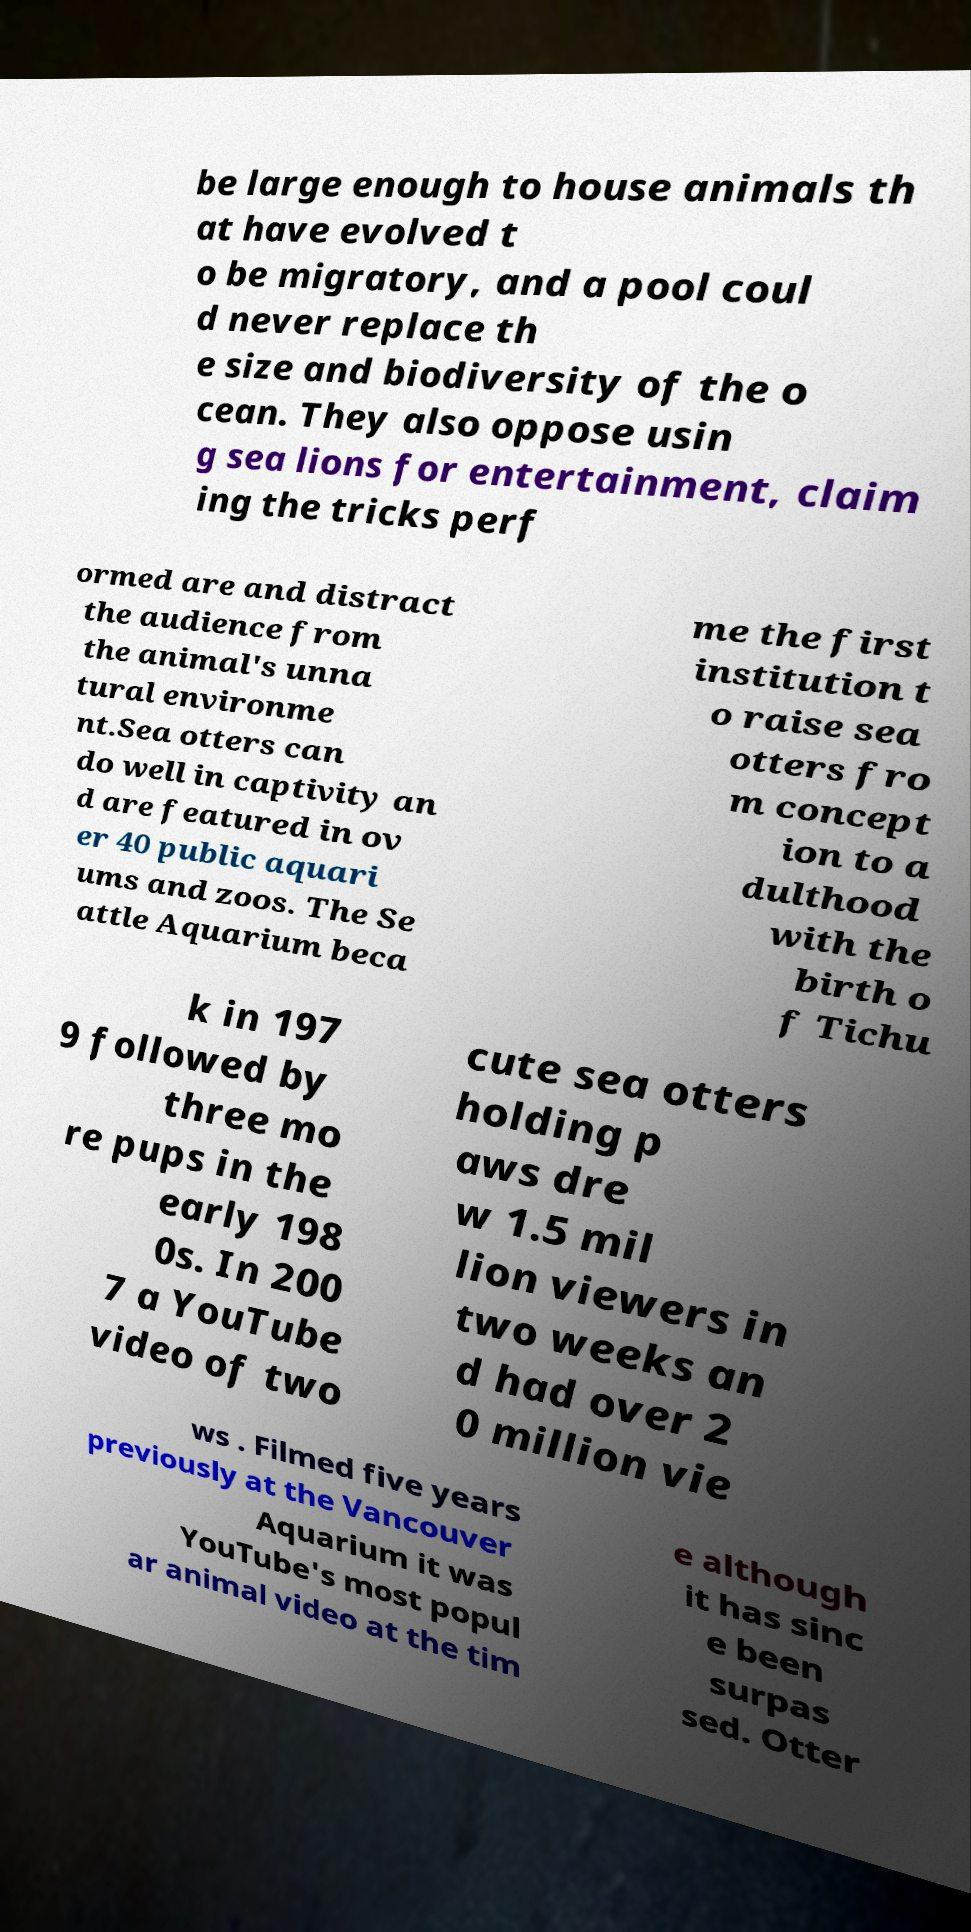Can you accurately transcribe the text from the provided image for me? be large enough to house animals th at have evolved t o be migratory, and a pool coul d never replace th e size and biodiversity of the o cean. They also oppose usin g sea lions for entertainment, claim ing the tricks perf ormed are and distract the audience from the animal's unna tural environme nt.Sea otters can do well in captivity an d are featured in ov er 40 public aquari ums and zoos. The Se attle Aquarium beca me the first institution t o raise sea otters fro m concept ion to a dulthood with the birth o f Tichu k in 197 9 followed by three mo re pups in the early 198 0s. In 200 7 a YouTube video of two cute sea otters holding p aws dre w 1.5 mil lion viewers in two weeks an d had over 2 0 million vie ws . Filmed five years previously at the Vancouver Aquarium it was YouTube's most popul ar animal video at the tim e although it has sinc e been surpas sed. Otter 